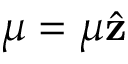<formula> <loc_0><loc_0><loc_500><loc_500>\mu = \mu \hat { z }</formula> 